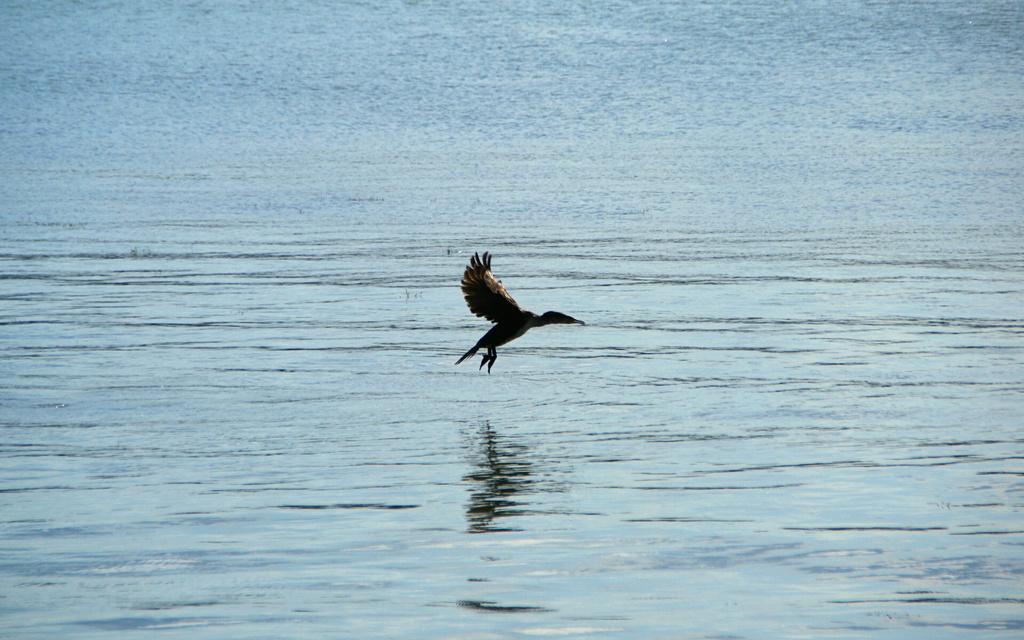Could you give a brief overview of what you see in this image? In this image in the middle, there is a bird, it is flying. At the bottom there are waves, water. 